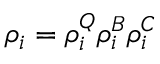<formula> <loc_0><loc_0><loc_500><loc_500>\rho _ { i } = \rho _ { i } ^ { Q } \rho _ { i } ^ { B } \rho _ { i } ^ { C }</formula> 